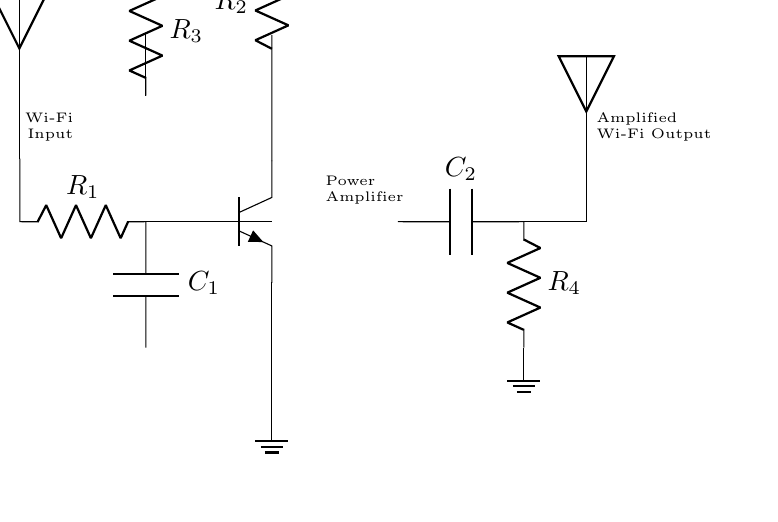What is the function of the component labeled R1? R1 is a resistor that serves to limit the current that enters the first part of the circuit from the Wi-Fi input. It helps prevent damage to other components by controlling the input current.
Answer: Resistor What type of signal does this circuit amplify? This circuit amplifies a Wi-Fi signal, which is an electronic communication signal. It is specifically designed to boost the strength of this signal for better connectivity.
Answer: Wi-Fi How many capacitors are present in the circuit? There are two capacitors, C1 and C2, which are used for filtering and coupling in the amplifier circuit, ensuring stable and enhanced signal amplification.
Answer: Two What is connected to the collector of the transistor Q1? The collector of Q1 is connected to a voltage source and a resistor (R2), forming part of the power supply setup that allows the transistor to amplify the signal.
Answer: Voltage source and resistor What type of transistor is used in this circuit? The circuit uses an npn transistor, which is common in amplifier circuits because it effectively controls and amplifies the current flow.
Answer: NPN Which component is used to improve signal strength in this circuit? The power amplifier, represented in the circuit, is the component responsible for enhancing the signal strength for better Wi-Fi coverage in the network.
Answer: Power amplifier 